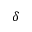<formula> <loc_0><loc_0><loc_500><loc_500>\delta</formula> 